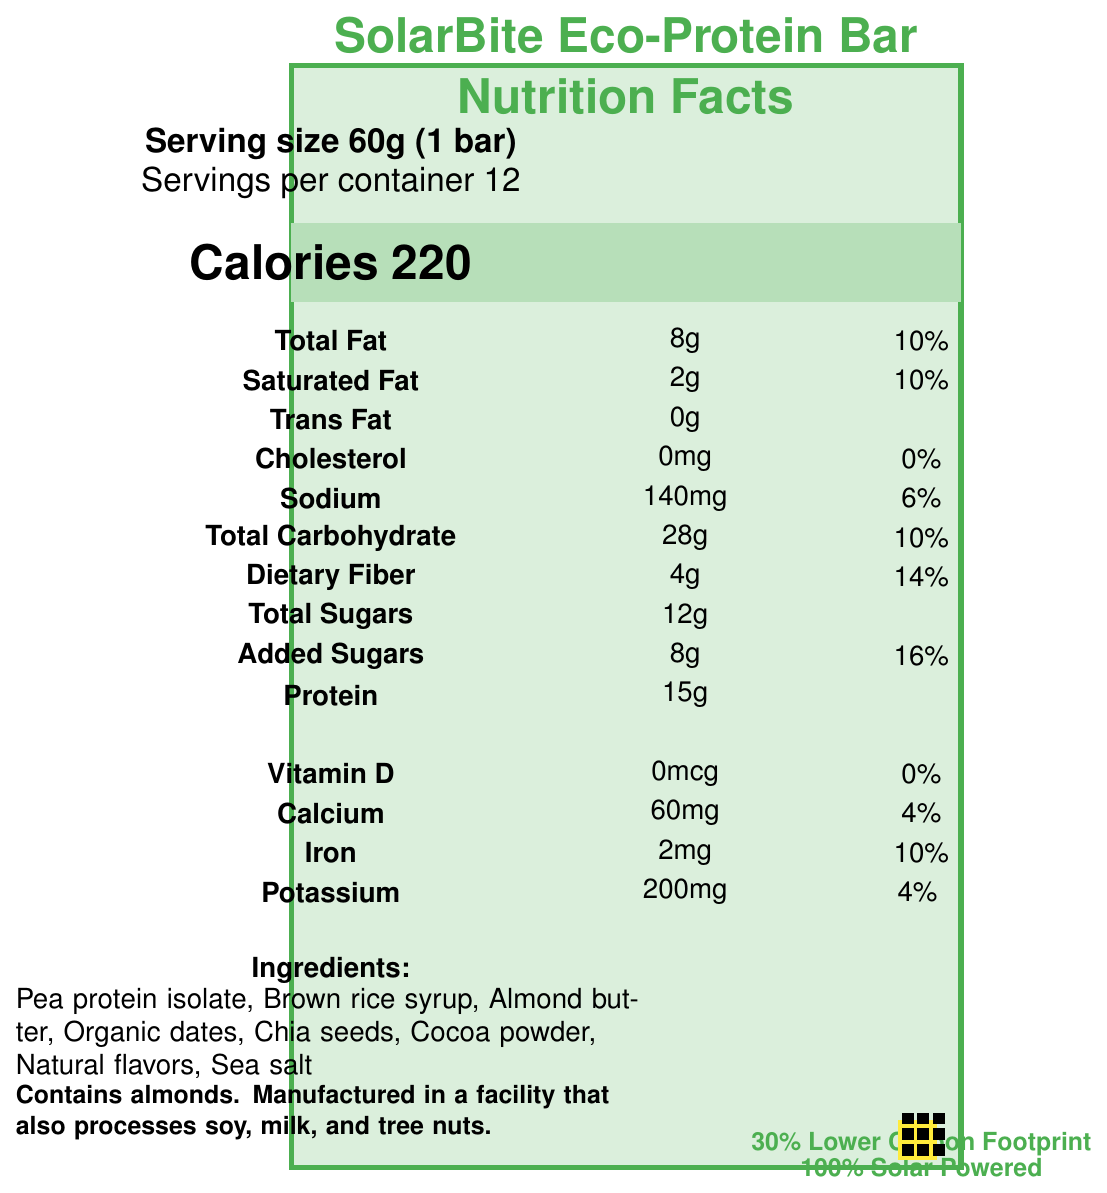What is the serving size of the SolarBite Eco-Protein Bar? This information is found at the top of the document under "Serving size 60g (1 bar)".
Answer: 60g (1 bar) How many servings are there per container? The document states "Servings per container 12" right below the serving size information.
Answer: 12 How many calories are in one SolarBite Eco-Protein Bar? The "Calories" section is highlighted and states "220".
Answer: 220 How much protein does one SolarBite Eco-Protein Bar contain? The "Protein" section lists "15g".
Answer: 15g What ingredient is listed first on the SolarBite Eco-Protein Bar ingredients list? The first ingredient listed under "Ingredients:" is "Pea protein isolate".
Answer: Pea protein isolate Which of the following certifications does the SolarBite Eco-Protein Bar have? A. USDA Organic B. Fair Trade Certified C. Gluten-Free D. Non-GMO Project Verified E. B and D The "sustainability certifications" section lists "USDA Organic" and "Non-GMO Project Verified".
Answer: E What is the daily value percentage of dietary fiber per serving? A. 10% B. 14% C. 16% D. 4% The "Dietary Fiber" section shows 4g and a daily value of "14%".
Answer: B Is there trans fat present in the SolarBite Eco-Protein Bar? The document lists "Trans Fat: 0g", indicating that there is no trans fat.
Answer: No Describe the eco-friendly features of the SolarBite Eco-Protein Bar. The "eco_friendly_features" section details these attributes about the product's sustainable features.
Answer: The SolarBite Eco-Protein Bar features 100% compostable packaging made from plant-based materials, has a 30% lower carbon footprint compared to conventional protein bars, and is produced using 100% solar energy from the factory's rooftop solar panels. How much cholesterol is in one serving of the SolarBite Eco-Protein Bar? The "Cholesterol" section indicates "0mg".
Answer: 0mg Which allergen is specifically mentioned in the document? The "allergen_info" section states "Contains almonds".
Answer: Almonds What minerals and vitamins are listed with their daily value percentages? The "Vitamin and mineral info" section lists these nutrients along with their amounts and daily values.
Answer: Vitamin D, Calcium, Iron, Potassium Can you determine the manufacturing process details for the SolarBite Eco-Protein Bar from the document? The document does not provide specific details about the manufacturing process aside from it being powered by solar energy.
Answer: No How much sugar, including added sugars, does one bar contain? The document lists "Total Sugars: 12g" and "Added Sugars: 8g", so the total is 20g.
Answer: 20g Is the SolarBite Eco-Protein Bar USDA Organic certified? It is listed under "sustainability_certifications".
Answer: Yes Does the document provide the specific carbon footprint per bar? The "carbon_footprint_reduction" section states that each bar saves "0.2 kg CO2e".
Answer: Yes What is the company message regarding their SolarBite Eco-Protein Bar? The company message at the end of the document provides this information.
Answer: At SolarBite, we're committed to providing you with high-quality, eco-friendly nutrition. Our solar-powered production facility has reduced our energy costs by 70%, allowing us to invest in sustainable ingredients and packaging. Join us in our mission to fuel your body and protect the planet! 